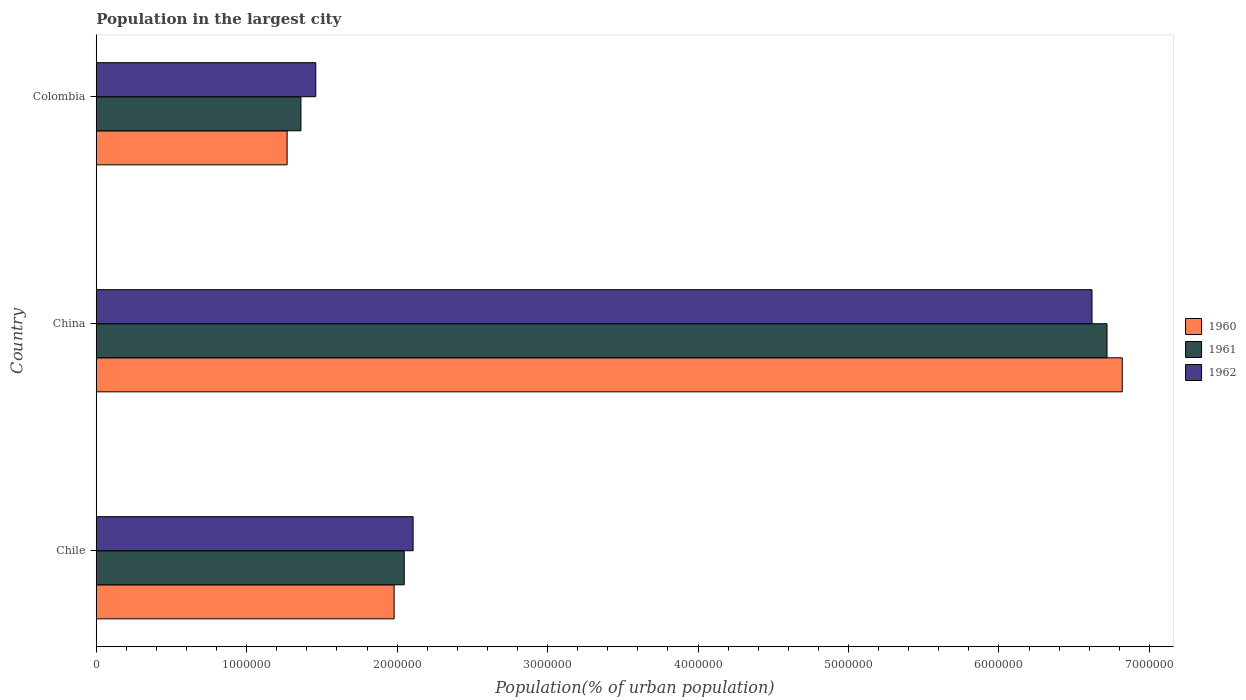How many groups of bars are there?
Make the answer very short. 3. How many bars are there on the 1st tick from the bottom?
Your answer should be very brief. 3. In how many cases, is the number of bars for a given country not equal to the number of legend labels?
Keep it short and to the point. 0. What is the population in the largest city in 1961 in Chile?
Ensure brevity in your answer.  2.05e+06. Across all countries, what is the maximum population in the largest city in 1961?
Your answer should be very brief. 6.72e+06. Across all countries, what is the minimum population in the largest city in 1960?
Provide a succinct answer. 1.27e+06. In which country was the population in the largest city in 1961 maximum?
Your answer should be compact. China. What is the total population in the largest city in 1962 in the graph?
Your answer should be compact. 1.02e+07. What is the difference between the population in the largest city in 1960 in Chile and that in China?
Offer a very short reply. -4.84e+06. What is the difference between the population in the largest city in 1962 in China and the population in the largest city in 1960 in Colombia?
Ensure brevity in your answer.  5.35e+06. What is the average population in the largest city in 1962 per country?
Offer a very short reply. 3.39e+06. What is the difference between the population in the largest city in 1962 and population in the largest city in 1961 in Colombia?
Provide a short and direct response. 9.86e+04. In how many countries, is the population in the largest city in 1962 greater than 200000 %?
Offer a very short reply. 3. What is the ratio of the population in the largest city in 1960 in Chile to that in China?
Provide a short and direct response. 0.29. Is the population in the largest city in 1962 in Chile less than that in Colombia?
Ensure brevity in your answer.  No. Is the difference between the population in the largest city in 1962 in China and Colombia greater than the difference between the population in the largest city in 1961 in China and Colombia?
Your answer should be compact. No. What is the difference between the highest and the second highest population in the largest city in 1961?
Your answer should be compact. 4.67e+06. What is the difference between the highest and the lowest population in the largest city in 1960?
Offer a terse response. 5.55e+06. In how many countries, is the population in the largest city in 1961 greater than the average population in the largest city in 1961 taken over all countries?
Keep it short and to the point. 1. What does the 3rd bar from the bottom in China represents?
Offer a very short reply. 1962. Is it the case that in every country, the sum of the population in the largest city in 1960 and population in the largest city in 1962 is greater than the population in the largest city in 1961?
Make the answer very short. Yes. How many countries are there in the graph?
Offer a terse response. 3. Are the values on the major ticks of X-axis written in scientific E-notation?
Keep it short and to the point. No. Does the graph contain any zero values?
Your answer should be compact. No. How are the legend labels stacked?
Provide a succinct answer. Vertical. What is the title of the graph?
Offer a terse response. Population in the largest city. What is the label or title of the X-axis?
Your answer should be compact. Population(% of urban population). What is the Population(% of urban population) in 1960 in Chile?
Your answer should be very brief. 1.98e+06. What is the Population(% of urban population) of 1961 in Chile?
Provide a short and direct response. 2.05e+06. What is the Population(% of urban population) in 1962 in Chile?
Offer a very short reply. 2.11e+06. What is the Population(% of urban population) in 1960 in China?
Make the answer very short. 6.82e+06. What is the Population(% of urban population) in 1961 in China?
Provide a short and direct response. 6.72e+06. What is the Population(% of urban population) in 1962 in China?
Your answer should be compact. 6.62e+06. What is the Population(% of urban population) in 1960 in Colombia?
Give a very brief answer. 1.27e+06. What is the Population(% of urban population) in 1961 in Colombia?
Provide a succinct answer. 1.36e+06. What is the Population(% of urban population) in 1962 in Colombia?
Provide a short and direct response. 1.46e+06. Across all countries, what is the maximum Population(% of urban population) in 1960?
Offer a very short reply. 6.82e+06. Across all countries, what is the maximum Population(% of urban population) of 1961?
Offer a terse response. 6.72e+06. Across all countries, what is the maximum Population(% of urban population) of 1962?
Ensure brevity in your answer.  6.62e+06. Across all countries, what is the minimum Population(% of urban population) in 1960?
Your response must be concise. 1.27e+06. Across all countries, what is the minimum Population(% of urban population) of 1961?
Your answer should be very brief. 1.36e+06. Across all countries, what is the minimum Population(% of urban population) of 1962?
Offer a very short reply. 1.46e+06. What is the total Population(% of urban population) of 1960 in the graph?
Your answer should be compact. 1.01e+07. What is the total Population(% of urban population) of 1961 in the graph?
Your response must be concise. 1.01e+07. What is the total Population(% of urban population) of 1962 in the graph?
Provide a short and direct response. 1.02e+07. What is the difference between the Population(% of urban population) of 1960 in Chile and that in China?
Provide a succinct answer. -4.84e+06. What is the difference between the Population(% of urban population) of 1961 in Chile and that in China?
Keep it short and to the point. -4.67e+06. What is the difference between the Population(% of urban population) in 1962 in Chile and that in China?
Give a very brief answer. -4.51e+06. What is the difference between the Population(% of urban population) of 1960 in Chile and that in Colombia?
Your response must be concise. 7.11e+05. What is the difference between the Population(% of urban population) of 1961 in Chile and that in Colombia?
Your response must be concise. 6.87e+05. What is the difference between the Population(% of urban population) of 1962 in Chile and that in Colombia?
Provide a short and direct response. 6.47e+05. What is the difference between the Population(% of urban population) of 1960 in China and that in Colombia?
Provide a succinct answer. 5.55e+06. What is the difference between the Population(% of urban population) of 1961 in China and that in Colombia?
Keep it short and to the point. 5.36e+06. What is the difference between the Population(% of urban population) in 1962 in China and that in Colombia?
Give a very brief answer. 5.16e+06. What is the difference between the Population(% of urban population) in 1960 in Chile and the Population(% of urban population) in 1961 in China?
Give a very brief answer. -4.74e+06. What is the difference between the Population(% of urban population) in 1960 in Chile and the Population(% of urban population) in 1962 in China?
Offer a very short reply. -4.64e+06. What is the difference between the Population(% of urban population) of 1961 in Chile and the Population(% of urban population) of 1962 in China?
Make the answer very short. -4.57e+06. What is the difference between the Population(% of urban population) in 1960 in Chile and the Population(% of urban population) in 1961 in Colombia?
Provide a short and direct response. 6.20e+05. What is the difference between the Population(% of urban population) in 1960 in Chile and the Population(% of urban population) in 1962 in Colombia?
Provide a short and direct response. 5.21e+05. What is the difference between the Population(% of urban population) of 1961 in Chile and the Population(% of urban population) of 1962 in Colombia?
Make the answer very short. 5.88e+05. What is the difference between the Population(% of urban population) in 1960 in China and the Population(% of urban population) in 1961 in Colombia?
Offer a terse response. 5.46e+06. What is the difference between the Population(% of urban population) of 1960 in China and the Population(% of urban population) of 1962 in Colombia?
Offer a terse response. 5.36e+06. What is the difference between the Population(% of urban population) in 1961 in China and the Population(% of urban population) in 1962 in Colombia?
Your response must be concise. 5.26e+06. What is the average Population(% of urban population) of 1960 per country?
Your response must be concise. 3.36e+06. What is the average Population(% of urban population) in 1961 per country?
Give a very brief answer. 3.38e+06. What is the average Population(% of urban population) in 1962 per country?
Make the answer very short. 3.39e+06. What is the difference between the Population(% of urban population) of 1960 and Population(% of urban population) of 1961 in Chile?
Provide a short and direct response. -6.71e+04. What is the difference between the Population(% of urban population) of 1960 and Population(% of urban population) of 1962 in Chile?
Your answer should be very brief. -1.26e+05. What is the difference between the Population(% of urban population) of 1961 and Population(% of urban population) of 1962 in Chile?
Your answer should be compact. -5.90e+04. What is the difference between the Population(% of urban population) in 1960 and Population(% of urban population) in 1961 in China?
Offer a terse response. 1.01e+05. What is the difference between the Population(% of urban population) in 1960 and Population(% of urban population) in 1962 in China?
Provide a succinct answer. 2.01e+05. What is the difference between the Population(% of urban population) in 1961 and Population(% of urban population) in 1962 in China?
Ensure brevity in your answer.  9.99e+04. What is the difference between the Population(% of urban population) of 1960 and Population(% of urban population) of 1961 in Colombia?
Make the answer very short. -9.18e+04. What is the difference between the Population(% of urban population) in 1960 and Population(% of urban population) in 1962 in Colombia?
Offer a terse response. -1.90e+05. What is the difference between the Population(% of urban population) in 1961 and Population(% of urban population) in 1962 in Colombia?
Your answer should be very brief. -9.86e+04. What is the ratio of the Population(% of urban population) in 1960 in Chile to that in China?
Make the answer very short. 0.29. What is the ratio of the Population(% of urban population) of 1961 in Chile to that in China?
Give a very brief answer. 0.3. What is the ratio of the Population(% of urban population) in 1962 in Chile to that in China?
Ensure brevity in your answer.  0.32. What is the ratio of the Population(% of urban population) in 1960 in Chile to that in Colombia?
Offer a terse response. 1.56. What is the ratio of the Population(% of urban population) of 1961 in Chile to that in Colombia?
Make the answer very short. 1.5. What is the ratio of the Population(% of urban population) of 1962 in Chile to that in Colombia?
Offer a very short reply. 1.44. What is the ratio of the Population(% of urban population) of 1960 in China to that in Colombia?
Your answer should be compact. 5.38. What is the ratio of the Population(% of urban population) of 1961 in China to that in Colombia?
Keep it short and to the point. 4.94. What is the ratio of the Population(% of urban population) in 1962 in China to that in Colombia?
Make the answer very short. 4.54. What is the difference between the highest and the second highest Population(% of urban population) in 1960?
Offer a very short reply. 4.84e+06. What is the difference between the highest and the second highest Population(% of urban population) in 1961?
Make the answer very short. 4.67e+06. What is the difference between the highest and the second highest Population(% of urban population) in 1962?
Your answer should be compact. 4.51e+06. What is the difference between the highest and the lowest Population(% of urban population) in 1960?
Make the answer very short. 5.55e+06. What is the difference between the highest and the lowest Population(% of urban population) of 1961?
Offer a very short reply. 5.36e+06. What is the difference between the highest and the lowest Population(% of urban population) in 1962?
Make the answer very short. 5.16e+06. 